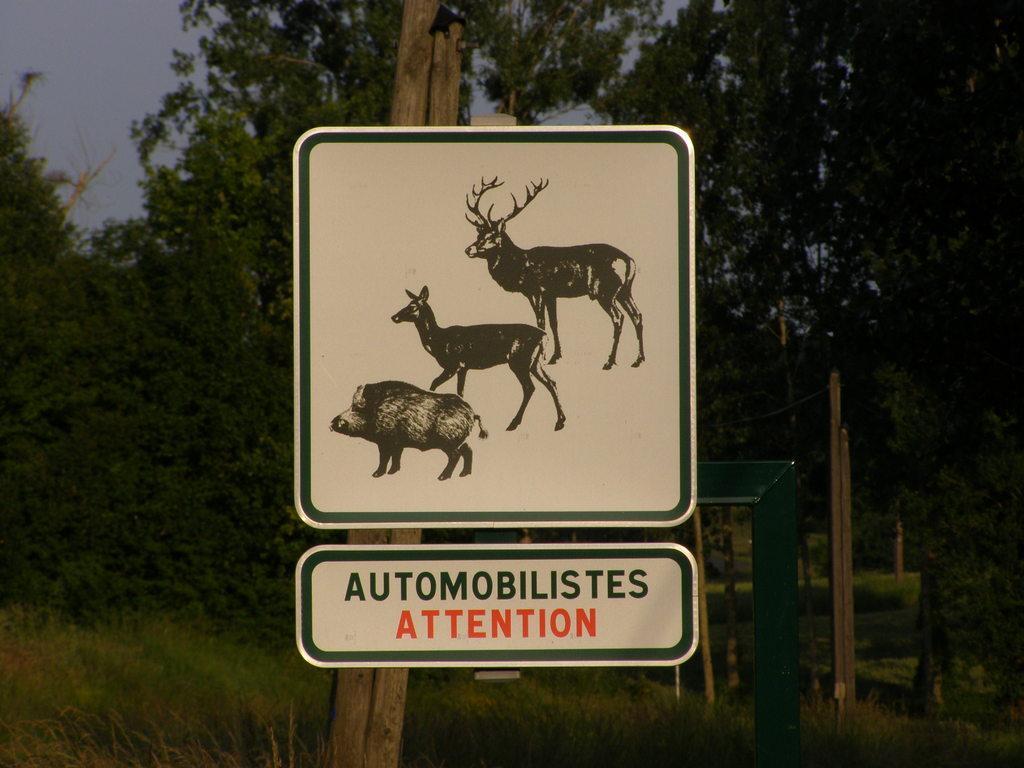Could you give a brief overview of what you see in this image? In this picture I see a wooden pole on which there are 2 boards and on one of the board I see 3 animals and on another board I see something is written. In the background I see the plants, trees, few more poles and the sky. 